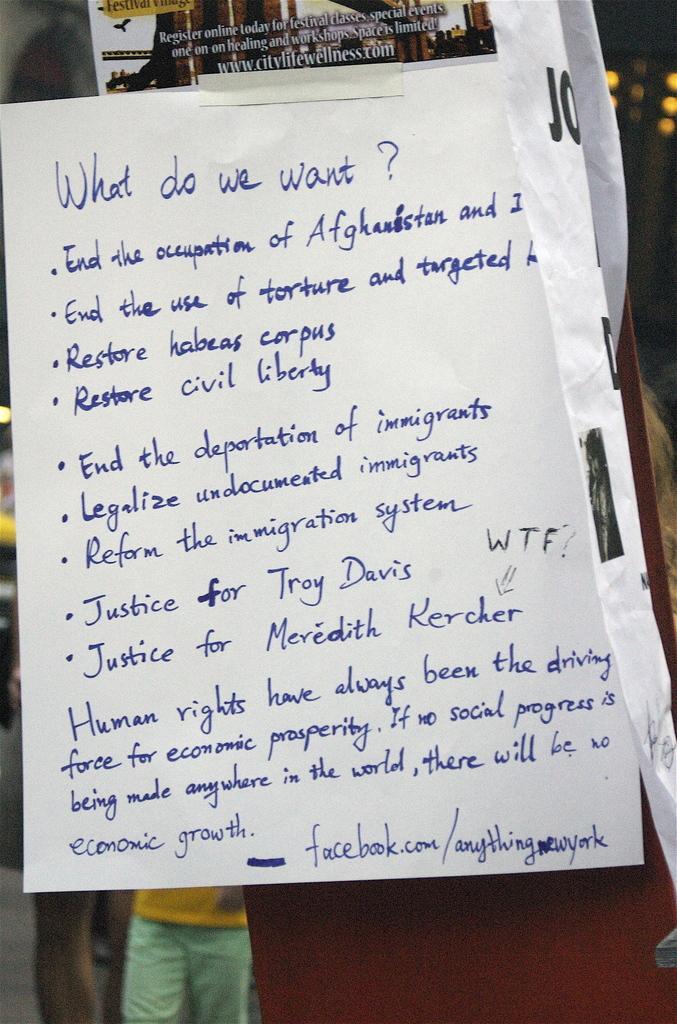Please provide a concise description of this image. In this image in the front there is a paper with some text written on it. In the background there is a person and there is an object which is brown in colour. 